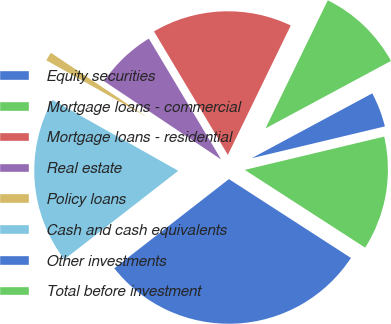Convert chart to OTSL. <chart><loc_0><loc_0><loc_500><loc_500><pie_chart><fcel>Equity securities<fcel>Mortgage loans - commercial<fcel>Mortgage loans - residential<fcel>Real estate<fcel>Policy loans<fcel>Cash and cash equivalents<fcel>Other investments<fcel>Total before investment<nl><fcel>4.12%<fcel>9.95%<fcel>15.78%<fcel>7.04%<fcel>1.21%<fcel>18.69%<fcel>30.35%<fcel>12.86%<nl></chart> 